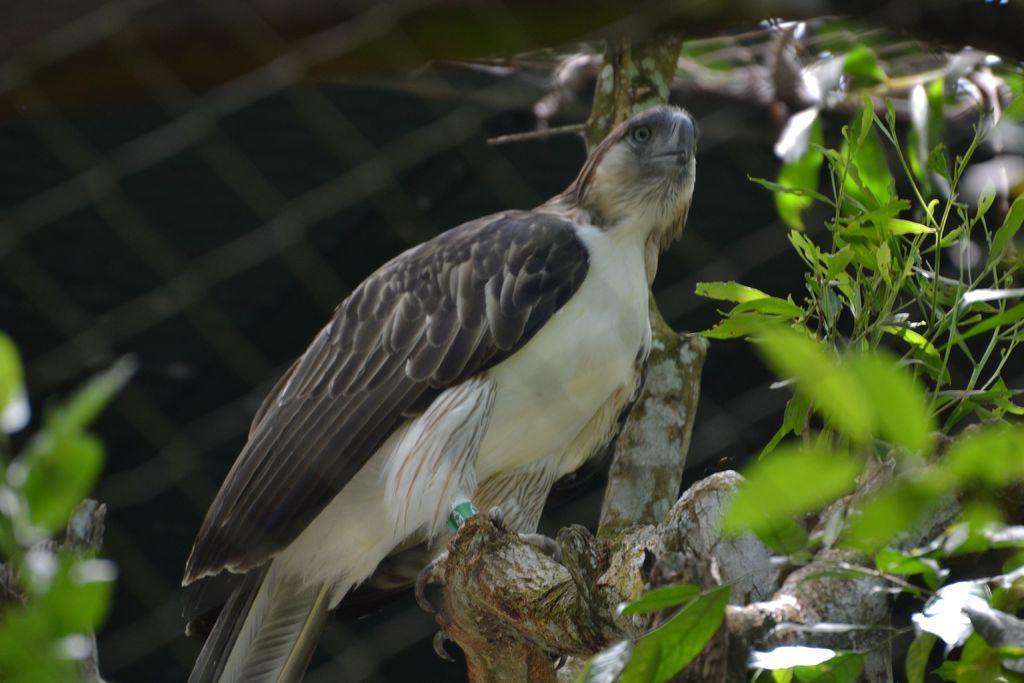Describe this image in one or two sentences. In this image there is a bird on the bark of a tree in the foreground. There are leaves in the left and right corner. And there is a mesh in the background. 